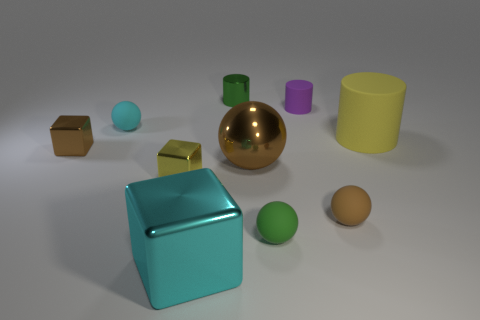Subtract all gray spheres. Subtract all gray blocks. How many spheres are left? 4 Subtract all balls. How many objects are left? 6 Add 2 brown metal cubes. How many brown metal cubes are left? 3 Add 1 rubber cylinders. How many rubber cylinders exist? 3 Subtract 0 blue cubes. How many objects are left? 10 Subtract all blocks. Subtract all purple cylinders. How many objects are left? 6 